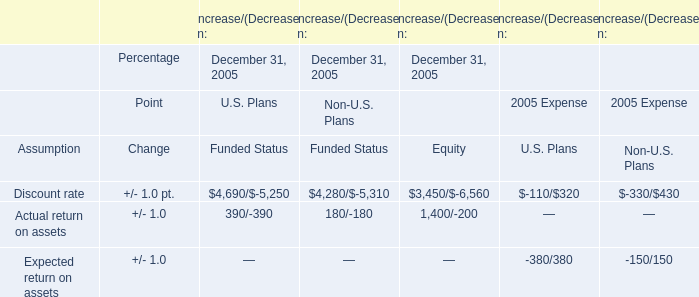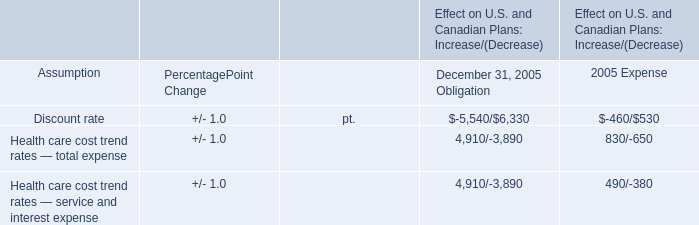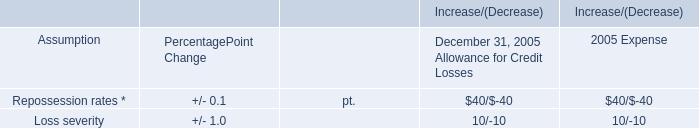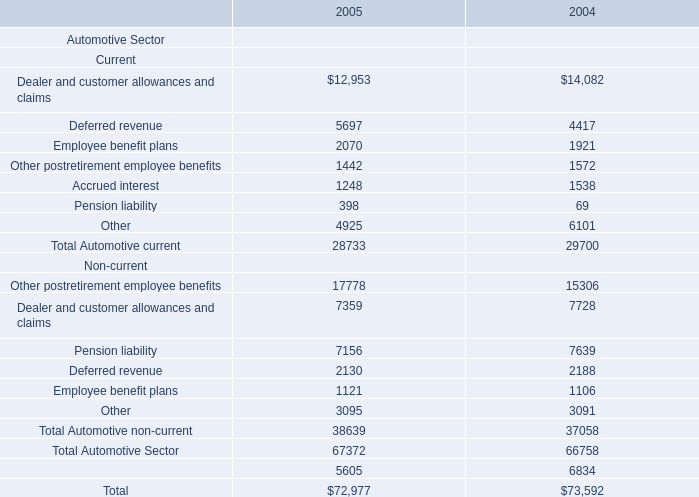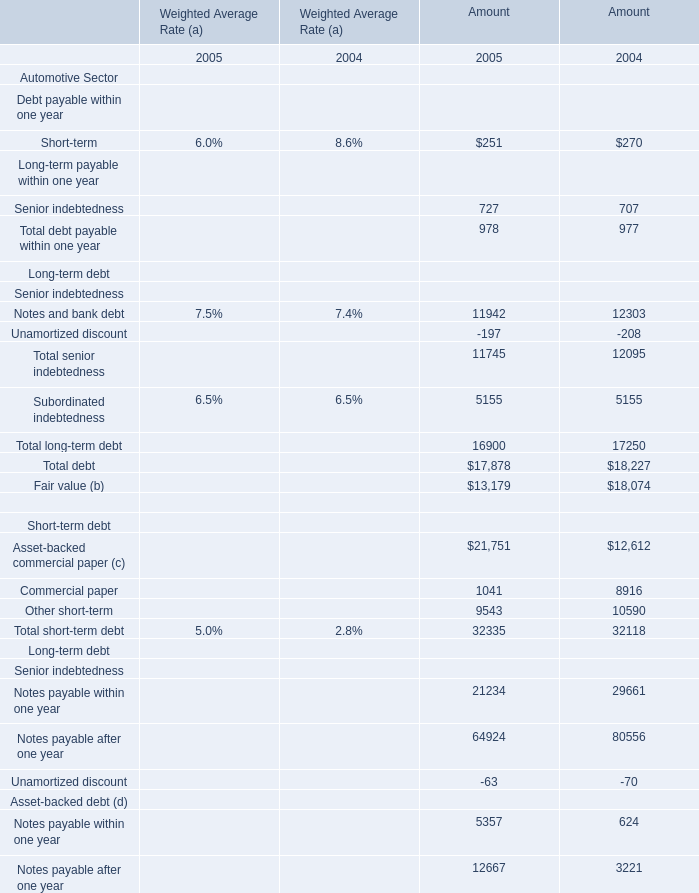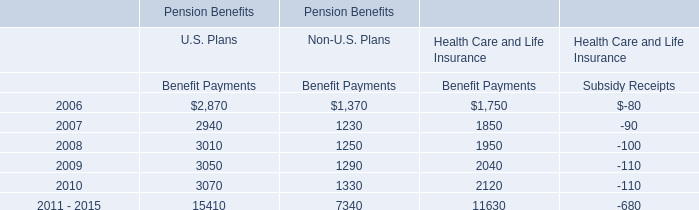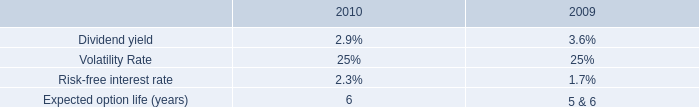what is the total tax benefits realized during 2011? 
Computations: (2 + 10)
Answer: 12.0. 